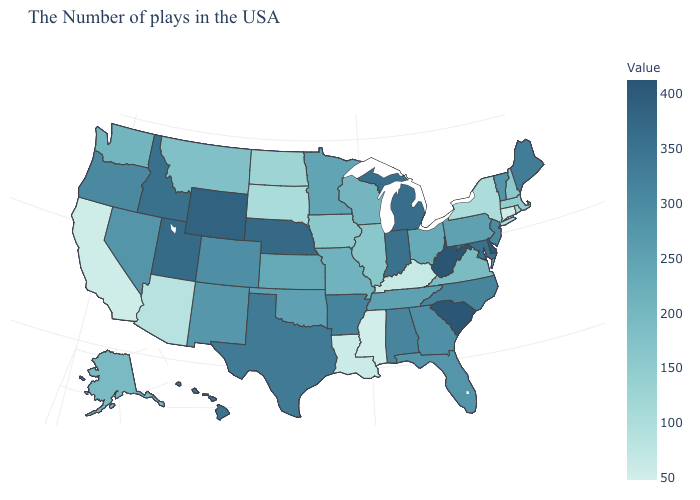Which states have the highest value in the USA?
Quick response, please. West Virginia. Is the legend a continuous bar?
Short answer required. Yes. Which states have the highest value in the USA?
Keep it brief. West Virginia. 